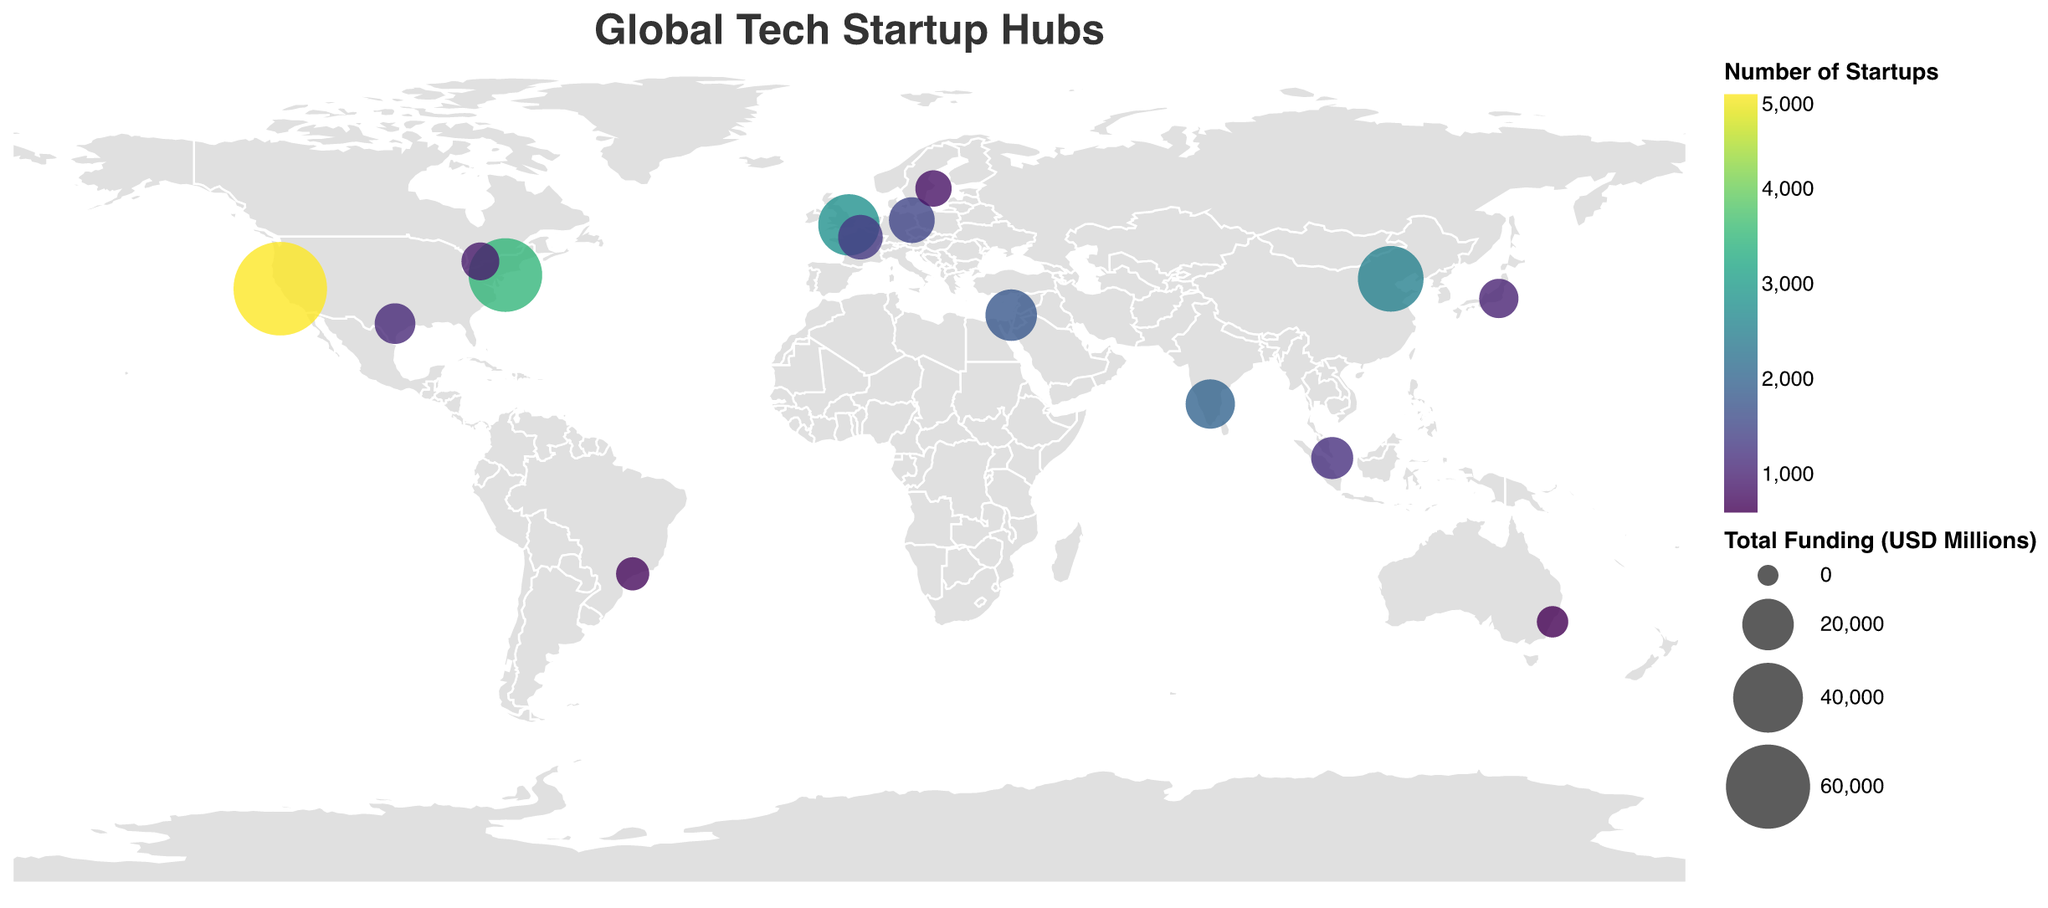Where is the tech startup hub with the highest total funding located? The figure shows that the tech startup hub with the largest circle, representing the highest total funding, is San Francisco in the USA.
Answer: San Francisco, USA How many tech startup hubs are shown on the map? By counting each circle representing a tech startup hub on the map, we can see there are a total of 15 hubs displayed.
Answer: 15 Which city has more startups, Berlin or Paris? The tooltip data indicates Berlin has 1,500 startups, while Paris has 1,300 startups.
Answer: Berlin What is the total funding in USD millions for tech startups in Beijing? The tooltip for Beijing shows the Total Funding in USD Millions as $35,000.
Answer: 35,000 Which city has the fewest startups? The smallest circle representing the least number of startups is located in Sydney, which is identified by the tooltip indicating 600 startups.
Answer: Sydney How does the total funding of New York compare to that of London? New York has a total funding of $45,000 million, while London has $30,000 million. Therefore, New York has $15,000 million more funding than London.
Answer: New York has $15,000 million more What’s the average number of startups between Tel Aviv, Bangalore, and Toronto? Tel Aviv has 1,800 startups, Bangalore has 2,000, and Toronto has 900. Sum: 1,800 + 2,000 + 900 = 4,700. Average: 4,700 / 3 = 1,566.67.
Answer: 1,567 Which city has the highest number of startups outside the USA? Excluding USA cities, the largest circle representing the highest number of startups is in London with 2,800 startups as indicated by the tooltip.
Answer: London Compare the number of startups in cities from the USA: San Francisco, New York, and Austin. Which city has the least? San Francisco has 5,000 startups, New York has 3,500, and Austin has 1,100. Austin has the fewest.
Answer: Austin What is the color range used to indicate the number of startups? The color range for the number of startups follows the "viridis" color scheme, which typically ranges from dark blues to bright yellows/greens.
Answer: Dark blue to bright yellow-green 